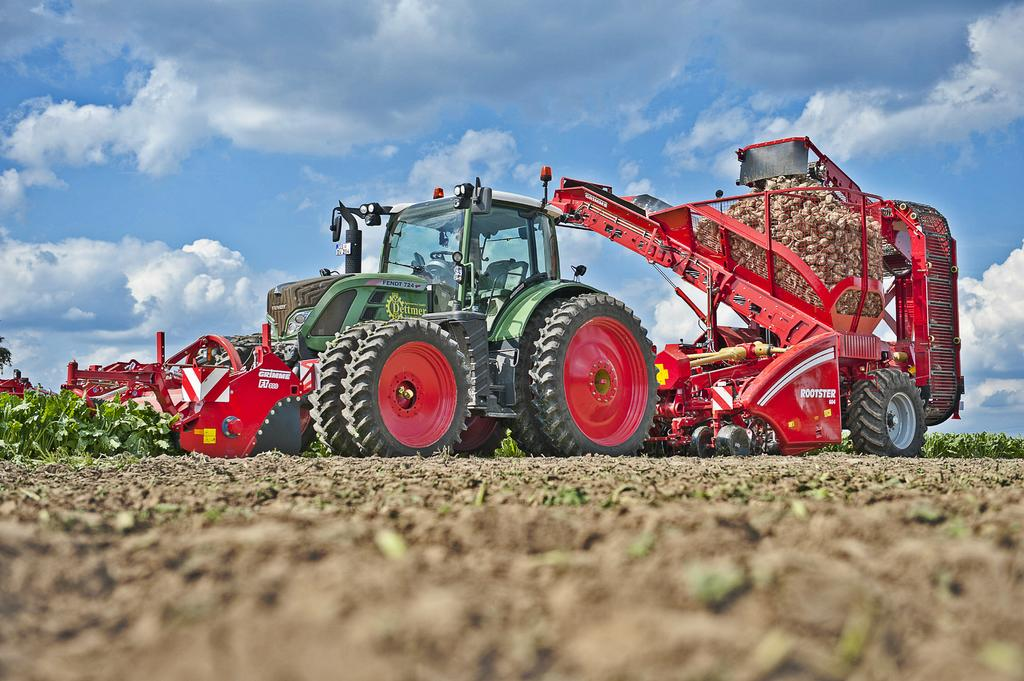What is the main subject of the image? The main subject of the image is a tractor. Where is the tractor located in the image? The tractor is located at the top side of the image. How does the tractor compete in the weightlifting competition in the image? There is no weightlifting competition or any indication of the tractor's weight in the image. 